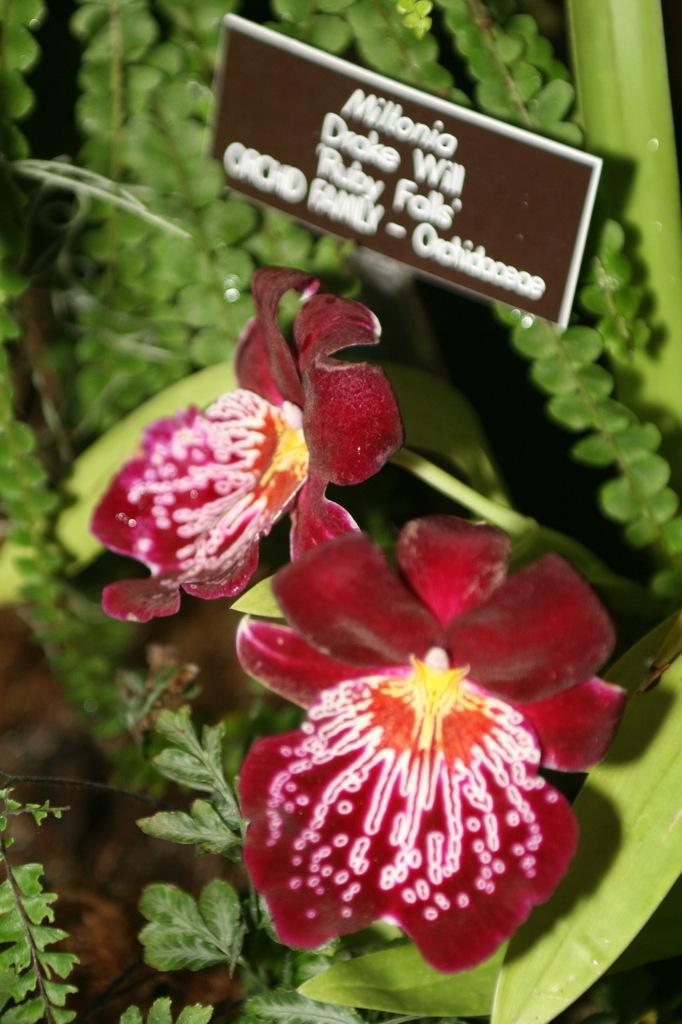Describe this image in one or two sentences. In this image in the foreground there are flowers and some plants, at the top of the image there is a board. On the board there is text, and on the right side of the image there are some leaves. 